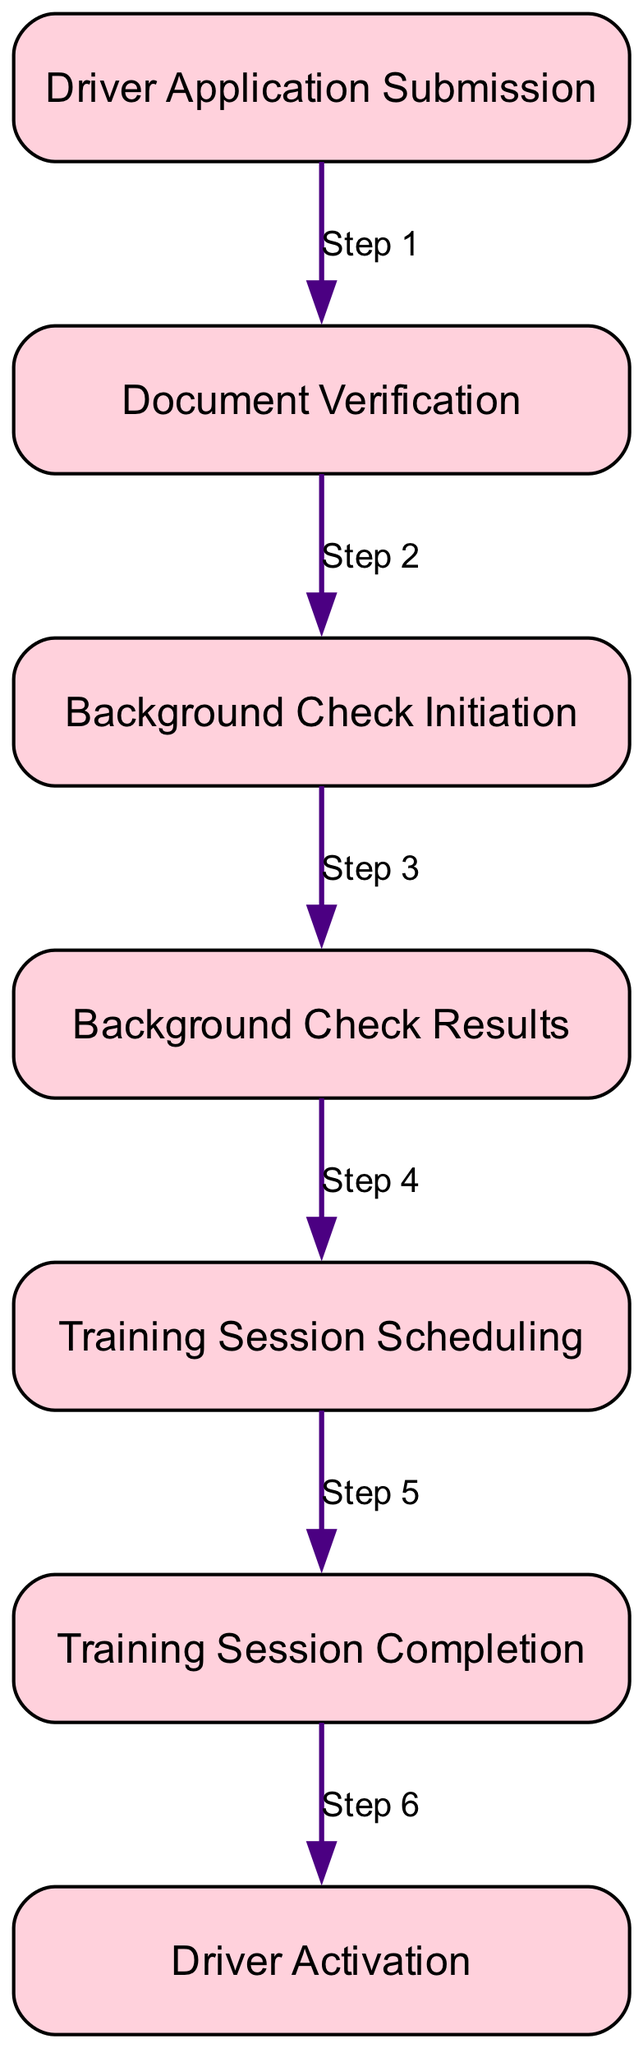What is the first step in the onboarding process? The diagram indicates that the first step is "Driver Application Submission." This can be seen as the very first node in the sequence of the diagram.
Answer: Driver Application Submission How many total steps are there in the diagram? The elements in the diagram include seven distinct steps; this can be counted directly from the listed nodes in the onboarding process.
Answer: Seven Which step follows "Document Verification"? According to the order of steps presented in the diagram, after "Document Verification" the subsequent step is "Background Check Initiation." This identifies the direct next connection in the sequence.
Answer: Background Check Initiation What is required for a driver to schedule training sessions? The diagram shows that a driver can schedule training sessions only after the background check is clear, making this an essential prerequisite for that action.
Answer: Background Check Clear At which step does the driver's account get activated? The last step in the sequence clearly states "Driver Activation," indicating that this occurs after training session completion.
Answer: Driver Activation What labels the edge between "Training Session Scheduling" and "Training Session Completion"? The label on the edge connecting these two steps, as represented in the diagram, is "Step 5," which signifies its sequence in the process flow.
Answer: Step 5 What triggers the "Background Check Results" step? According to the diagram, the "Background Check Results" are returned to Lyft after the initiation of the background check, establishing a cause and effect relationship.
Answer: Background Check Initiation What is the relation between "Driver Application Submission" and "Document Verification"? The relationship is that "Driver Application Submission" is the direct predecessor of "Document Verification," indicating that the latter can only occur after the former has taken place.
Answer: Step 1 